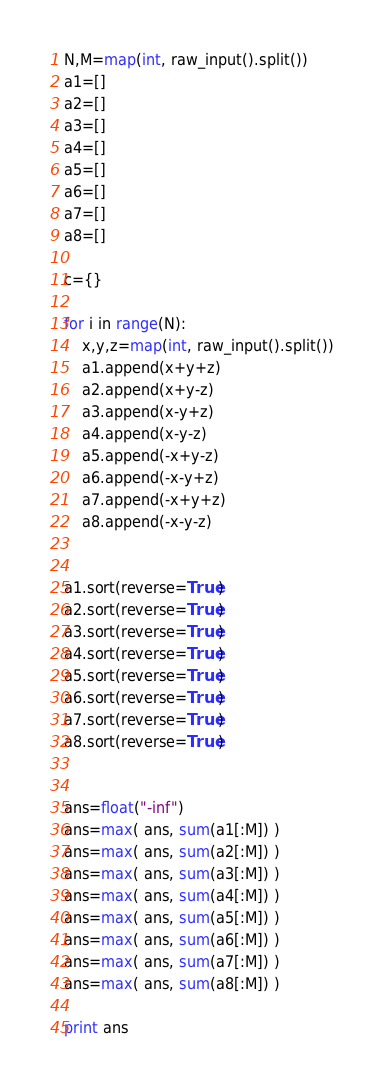<code> <loc_0><loc_0><loc_500><loc_500><_Python_>N,M=map(int, raw_input().split())
a1=[]
a2=[]
a3=[]
a4=[]
a5=[]
a6=[]
a7=[]
a8=[]

c={}

for i in range(N):
	x,y,z=map(int, raw_input().split())
	a1.append(x+y+z)
	a2.append(x+y-z)
	a3.append(x-y+z)
	a4.append(x-y-z)
	a5.append(-x+y-z)
	a6.append(-x-y+z)
	a7.append(-x+y+z)
	a8.append(-x-y-z)


a1.sort(reverse=True)
a2.sort(reverse=True)
a3.sort(reverse=True)
a4.sort(reverse=True)
a5.sort(reverse=True)
a6.sort(reverse=True)
a7.sort(reverse=True)
a8.sort(reverse=True)


ans=float("-inf")
ans=max( ans, sum(a1[:M]) )
ans=max( ans, sum(a2[:M]) )
ans=max( ans, sum(a3[:M]) )
ans=max( ans, sum(a4[:M]) )
ans=max( ans, sum(a5[:M]) )
ans=max( ans, sum(a6[:M]) )
ans=max( ans, sum(a7[:M]) )
ans=max( ans, sum(a8[:M]) )

print ans

</code> 